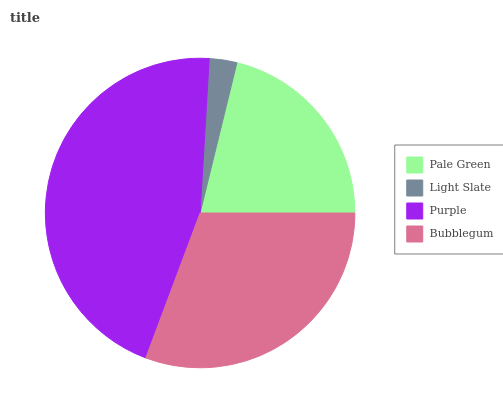Is Light Slate the minimum?
Answer yes or no. Yes. Is Purple the maximum?
Answer yes or no. Yes. Is Purple the minimum?
Answer yes or no. No. Is Light Slate the maximum?
Answer yes or no. No. Is Purple greater than Light Slate?
Answer yes or no. Yes. Is Light Slate less than Purple?
Answer yes or no. Yes. Is Light Slate greater than Purple?
Answer yes or no. No. Is Purple less than Light Slate?
Answer yes or no. No. Is Bubblegum the high median?
Answer yes or no. Yes. Is Pale Green the low median?
Answer yes or no. Yes. Is Light Slate the high median?
Answer yes or no. No. Is Bubblegum the low median?
Answer yes or no. No. 